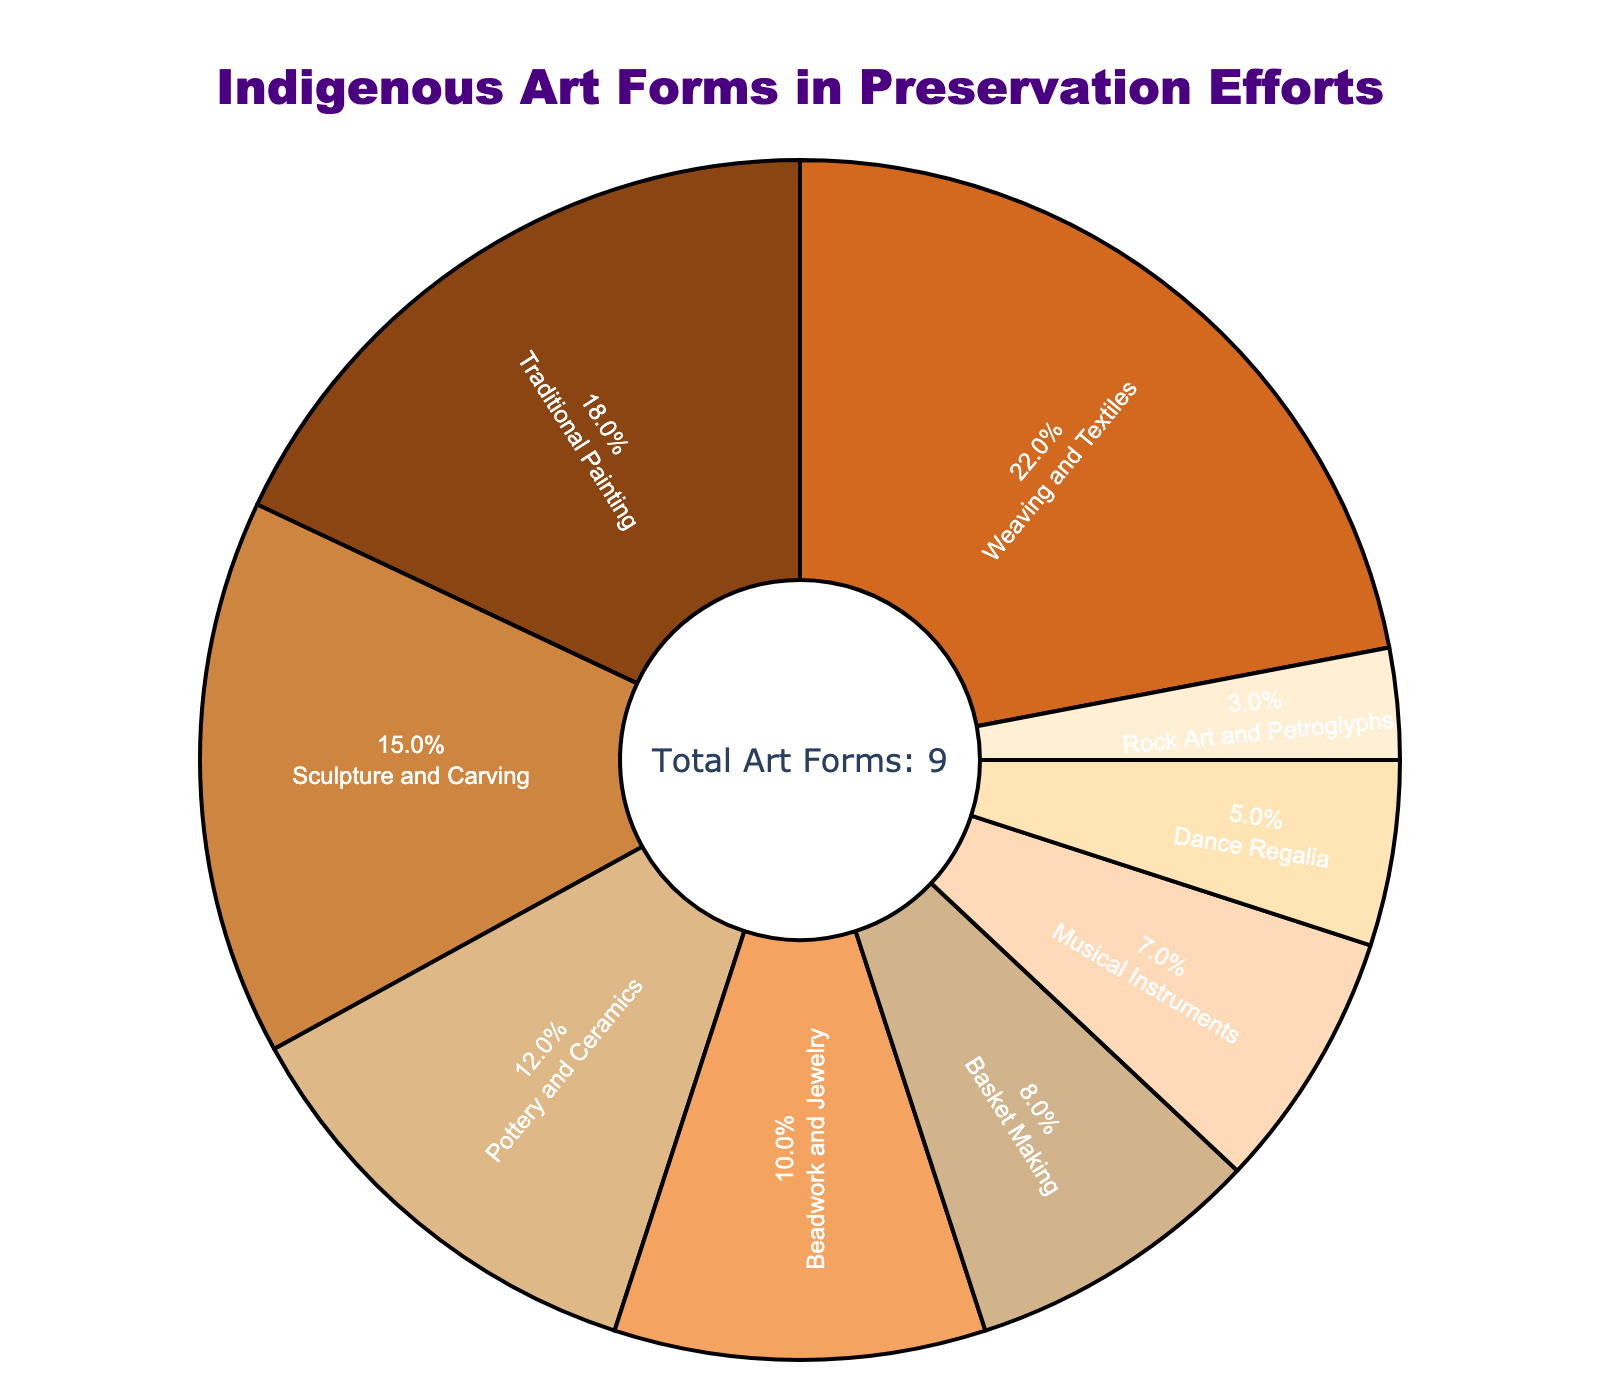What percentage of preservation efforts is directed towards Dance Regalia? Locate the Dance Regalia section on the pie chart and observe that it constitutes 5% of the preservation efforts.
Answer: 5% How much greater is the percentage representation of Weaving and Textiles compared to Beadwork and Jewelry? Weaving and Textiles have a percentage of 22%, while Beadwork and Jewelry have 10%. Subtracting the two (22% - 10%) gives the difference.
Answer: 12% If you sum the percentages of Traditional Painting, Pottery and Ceramics, and Beadwork and Jewelry, what is the total? Add the percentages of Traditional Painting (18%), Pottery and Ceramics (12%), and Beadwork and Jewelry (10%). That totals to 18% + 12% + 10% = 40%.
Answer: 40% Which art form has the smallest representation in preservation efforts? Observe the pie chart and see that Rock Art and Petroglyphs have the smallest representation at 3%.
Answer: Rock Art and Petroglyphs How does the representation of Basket Making compare to that of Sculpture and Carving? Basket Making constitutes 8% of the preservation efforts, while Sculpture and Carving constitute 15%. Basket Making has a smaller representation.
Answer: Basket Making is 7% less than Sculpture and Carving What is the cumulative percentage of Musical Instruments and Dance Regalia? Add the percentages of Musical Instruments (7%) and Dance Regalia (5%). That totals to 7% + 5% = 12%.
Answer: 12% Identify the art form with the second smallest percentage representation. Locate the sections of the chart with the smallest percentages and recognize that Dance Regalia, with 5%, has the second smallest representation.
Answer: Dance Regalia Which two art forms combined contribute nearly one-third of the preservation efforts? Observe the pie chart and notice that Weaving and Textiles (22%) and Traditional Painting (18%) together contribute 40%, which is close to one-third of the total (approximately 33.3%).
Answer: Weaving and Textiles and Traditional Painting What is the average percentage representation of Basket Making, Musical Instruments, and Rock Art and Petroglyphs? Add the percentages (Basket Making 8%, Musical Instruments 7%, Rock Art and Petroglyphs 3%) and divide by the number of art forms (3). (8% + 7% + 3%) / 3 = 18% / 3 = 6%.
Answer: 6% What color represents the Weaving and Textiles section on the pie chart? Observe the pie chart to see that Weaving and Textiles is represented by a specific color, which in this case is light brown (#D2691E).
Answer: Light Brown 